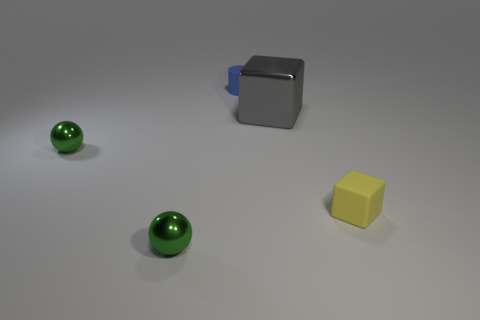Add 2 big gray cubes. How many objects exist? 7 Add 5 big metal objects. How many big metal objects are left? 6 Add 5 big gray metal objects. How many big gray metal objects exist? 6 Subtract all yellow cubes. How many cubes are left? 1 Subtract 0 yellow cylinders. How many objects are left? 5 Subtract all blocks. How many objects are left? 3 Subtract all gray cylinders. Subtract all gray blocks. How many cylinders are left? 1 Subtract all yellow cylinders. How many purple cubes are left? 0 Subtract all brown shiny balls. Subtract all tiny objects. How many objects are left? 1 